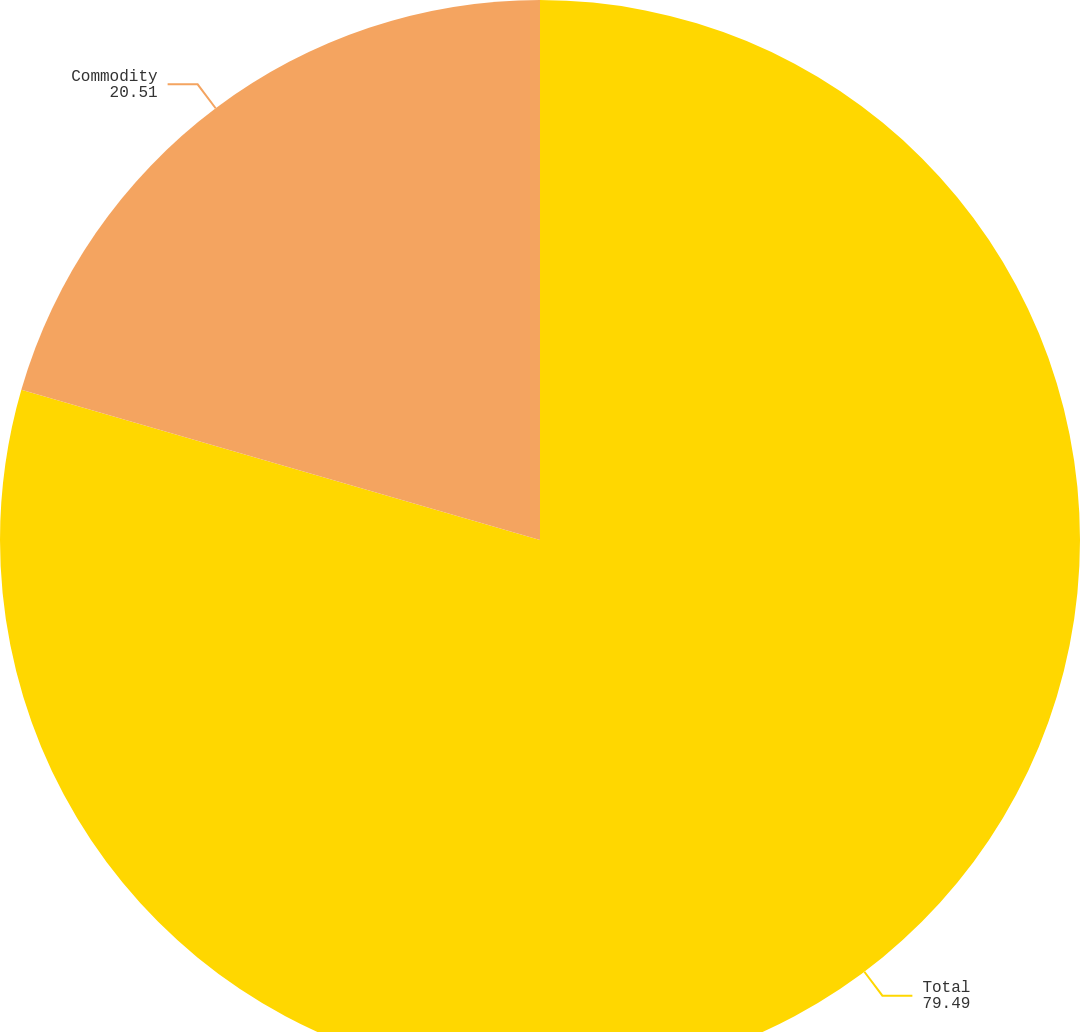<chart> <loc_0><loc_0><loc_500><loc_500><pie_chart><fcel>Total<fcel>Commodity<nl><fcel>79.49%<fcel>20.51%<nl></chart> 